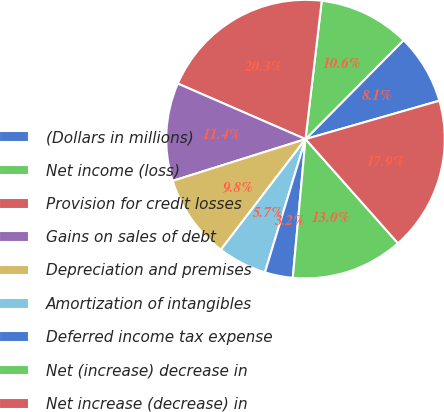Convert chart. <chart><loc_0><loc_0><loc_500><loc_500><pie_chart><fcel>(Dollars in millions)<fcel>Net income (loss)<fcel>Provision for credit losses<fcel>Gains on sales of debt<fcel>Depreciation and premises<fcel>Amortization of intangibles<fcel>Deferred income tax expense<fcel>Net (increase) decrease in<fcel>Net increase (decrease) in<nl><fcel>8.13%<fcel>10.57%<fcel>20.33%<fcel>11.38%<fcel>9.76%<fcel>5.69%<fcel>3.25%<fcel>13.01%<fcel>17.89%<nl></chart> 